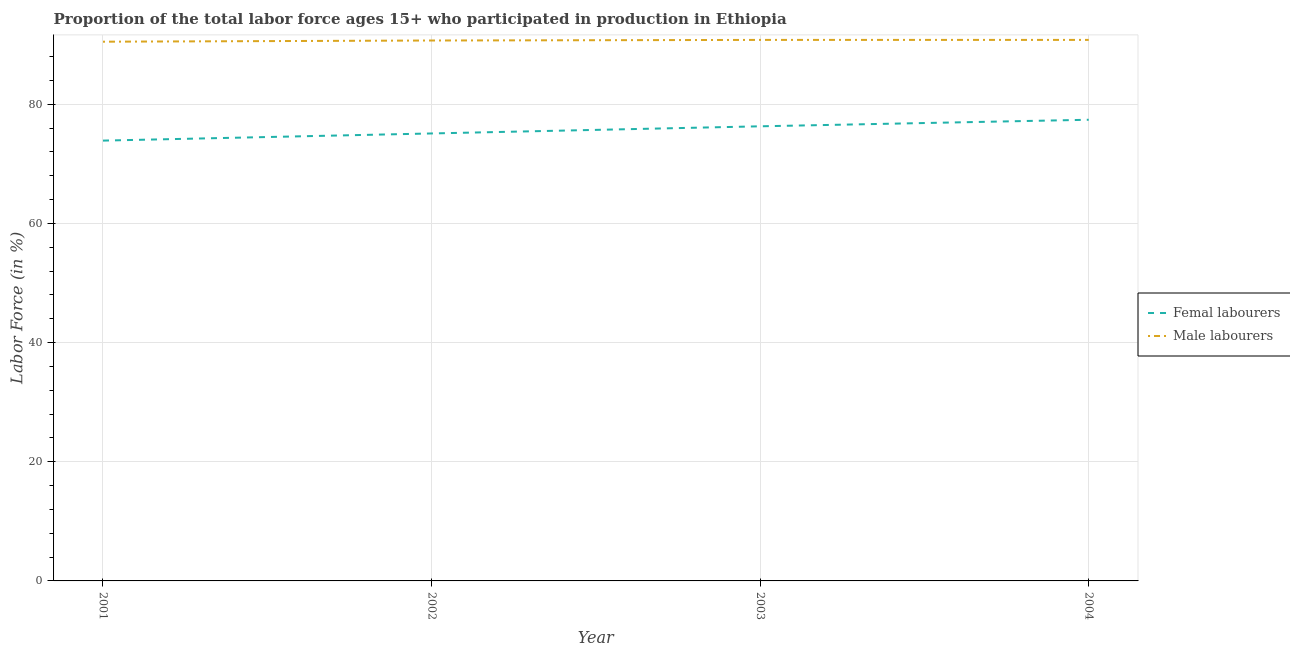How many different coloured lines are there?
Offer a terse response. 2. What is the percentage of female labor force in 2001?
Your answer should be very brief. 73.9. Across all years, what is the maximum percentage of female labor force?
Your response must be concise. 77.4. Across all years, what is the minimum percentage of male labour force?
Ensure brevity in your answer.  90.5. In which year was the percentage of male labour force minimum?
Offer a terse response. 2001. What is the total percentage of female labor force in the graph?
Offer a terse response. 302.7. What is the difference between the percentage of male labour force in 2002 and that in 2003?
Your answer should be very brief. -0.1. What is the difference between the percentage of male labour force in 2002 and the percentage of female labor force in 2003?
Provide a short and direct response. 14.4. What is the average percentage of female labor force per year?
Make the answer very short. 75.68. In the year 2002, what is the difference between the percentage of male labour force and percentage of female labor force?
Your answer should be very brief. 15.6. In how many years, is the percentage of male labour force greater than 84 %?
Ensure brevity in your answer.  4. What is the ratio of the percentage of female labor force in 2003 to that in 2004?
Your answer should be compact. 0.99. Is the percentage of male labour force in 2002 less than that in 2004?
Ensure brevity in your answer.  Yes. Is the difference between the percentage of male labour force in 2001 and 2002 greater than the difference between the percentage of female labor force in 2001 and 2002?
Your response must be concise. Yes. What is the difference between the highest and the second highest percentage of female labor force?
Keep it short and to the point. 1.1. In how many years, is the percentage of female labor force greater than the average percentage of female labor force taken over all years?
Make the answer very short. 2. Is the percentage of female labor force strictly greater than the percentage of male labour force over the years?
Provide a succinct answer. No. Is the percentage of male labour force strictly less than the percentage of female labor force over the years?
Ensure brevity in your answer.  No. How many lines are there?
Your answer should be compact. 2. What is the difference between two consecutive major ticks on the Y-axis?
Keep it short and to the point. 20. Does the graph contain any zero values?
Give a very brief answer. No. How many legend labels are there?
Make the answer very short. 2. How are the legend labels stacked?
Your response must be concise. Vertical. What is the title of the graph?
Keep it short and to the point. Proportion of the total labor force ages 15+ who participated in production in Ethiopia. What is the label or title of the X-axis?
Ensure brevity in your answer.  Year. What is the label or title of the Y-axis?
Offer a very short reply. Labor Force (in %). What is the Labor Force (in %) in Femal labourers in 2001?
Your answer should be very brief. 73.9. What is the Labor Force (in %) in Male labourers in 2001?
Your answer should be very brief. 90.5. What is the Labor Force (in %) of Femal labourers in 2002?
Provide a succinct answer. 75.1. What is the Labor Force (in %) in Male labourers in 2002?
Keep it short and to the point. 90.7. What is the Labor Force (in %) in Femal labourers in 2003?
Your response must be concise. 76.3. What is the Labor Force (in %) of Male labourers in 2003?
Your response must be concise. 90.8. What is the Labor Force (in %) in Femal labourers in 2004?
Give a very brief answer. 77.4. What is the Labor Force (in %) of Male labourers in 2004?
Ensure brevity in your answer.  90.8. Across all years, what is the maximum Labor Force (in %) of Femal labourers?
Provide a short and direct response. 77.4. Across all years, what is the maximum Labor Force (in %) of Male labourers?
Offer a very short reply. 90.8. Across all years, what is the minimum Labor Force (in %) in Femal labourers?
Your answer should be compact. 73.9. Across all years, what is the minimum Labor Force (in %) of Male labourers?
Provide a short and direct response. 90.5. What is the total Labor Force (in %) in Femal labourers in the graph?
Ensure brevity in your answer.  302.7. What is the total Labor Force (in %) in Male labourers in the graph?
Make the answer very short. 362.8. What is the difference between the Labor Force (in %) in Femal labourers in 2001 and that in 2002?
Your response must be concise. -1.2. What is the difference between the Labor Force (in %) of Femal labourers in 2001 and that in 2003?
Offer a very short reply. -2.4. What is the difference between the Labor Force (in %) of Male labourers in 2001 and that in 2003?
Ensure brevity in your answer.  -0.3. What is the difference between the Labor Force (in %) of Male labourers in 2001 and that in 2004?
Ensure brevity in your answer.  -0.3. What is the difference between the Labor Force (in %) of Femal labourers in 2002 and that in 2003?
Provide a succinct answer. -1.2. What is the difference between the Labor Force (in %) of Femal labourers in 2003 and that in 2004?
Provide a short and direct response. -1.1. What is the difference between the Labor Force (in %) of Femal labourers in 2001 and the Labor Force (in %) of Male labourers in 2002?
Keep it short and to the point. -16.8. What is the difference between the Labor Force (in %) in Femal labourers in 2001 and the Labor Force (in %) in Male labourers in 2003?
Your answer should be compact. -16.9. What is the difference between the Labor Force (in %) in Femal labourers in 2001 and the Labor Force (in %) in Male labourers in 2004?
Offer a very short reply. -16.9. What is the difference between the Labor Force (in %) in Femal labourers in 2002 and the Labor Force (in %) in Male labourers in 2003?
Provide a short and direct response. -15.7. What is the difference between the Labor Force (in %) in Femal labourers in 2002 and the Labor Force (in %) in Male labourers in 2004?
Give a very brief answer. -15.7. What is the difference between the Labor Force (in %) of Femal labourers in 2003 and the Labor Force (in %) of Male labourers in 2004?
Your answer should be compact. -14.5. What is the average Labor Force (in %) in Femal labourers per year?
Keep it short and to the point. 75.67. What is the average Labor Force (in %) of Male labourers per year?
Keep it short and to the point. 90.7. In the year 2001, what is the difference between the Labor Force (in %) of Femal labourers and Labor Force (in %) of Male labourers?
Ensure brevity in your answer.  -16.6. In the year 2002, what is the difference between the Labor Force (in %) of Femal labourers and Labor Force (in %) of Male labourers?
Your answer should be very brief. -15.6. In the year 2003, what is the difference between the Labor Force (in %) in Femal labourers and Labor Force (in %) in Male labourers?
Your response must be concise. -14.5. What is the ratio of the Labor Force (in %) in Femal labourers in 2001 to that in 2003?
Offer a very short reply. 0.97. What is the ratio of the Labor Force (in %) of Femal labourers in 2001 to that in 2004?
Give a very brief answer. 0.95. What is the ratio of the Labor Force (in %) of Male labourers in 2001 to that in 2004?
Your response must be concise. 1. What is the ratio of the Labor Force (in %) of Femal labourers in 2002 to that in 2003?
Offer a terse response. 0.98. What is the ratio of the Labor Force (in %) of Male labourers in 2002 to that in 2003?
Offer a terse response. 1. What is the ratio of the Labor Force (in %) of Femal labourers in 2002 to that in 2004?
Make the answer very short. 0.97. What is the ratio of the Labor Force (in %) in Femal labourers in 2003 to that in 2004?
Make the answer very short. 0.99. What is the difference between the highest and the lowest Labor Force (in %) of Femal labourers?
Give a very brief answer. 3.5. What is the difference between the highest and the lowest Labor Force (in %) in Male labourers?
Keep it short and to the point. 0.3. 